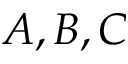Convert formula to latex. <formula><loc_0><loc_0><loc_500><loc_500>A , B , C</formula> 